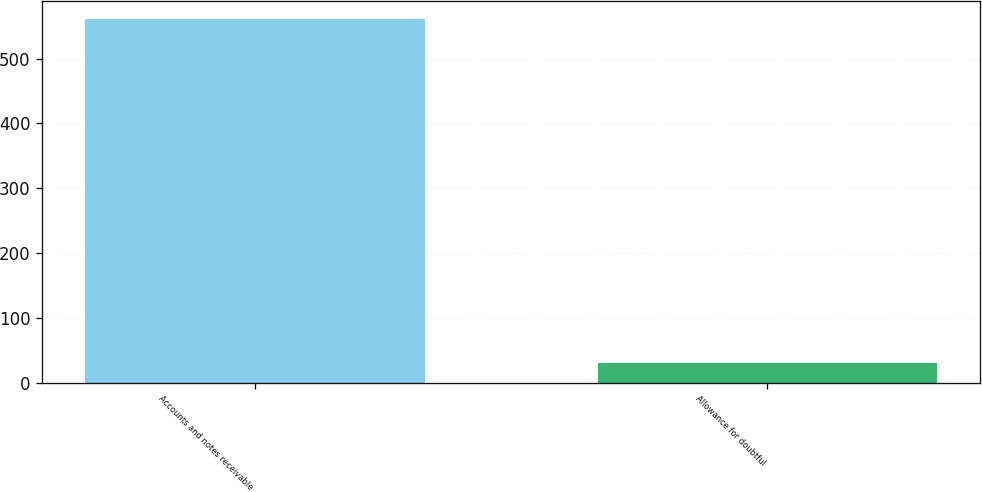Convert chart to OTSL. <chart><loc_0><loc_0><loc_500><loc_500><bar_chart><fcel>Accounts and notes receivable<fcel>Allowance for doubtful<nl><fcel>561<fcel>31<nl></chart> 